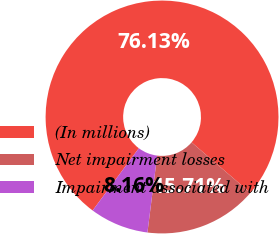Convert chart. <chart><loc_0><loc_0><loc_500><loc_500><pie_chart><fcel>(In millions)<fcel>Net impairment losses<fcel>Impairment associated with<nl><fcel>76.13%<fcel>15.71%<fcel>8.16%<nl></chart> 